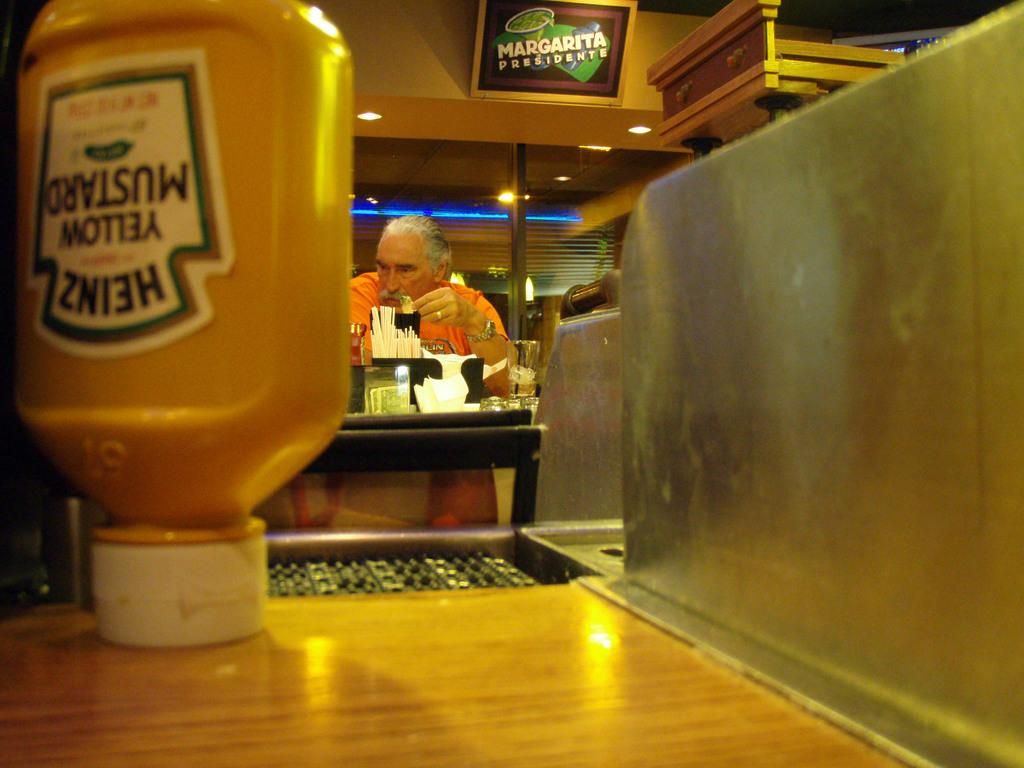Provide a one-sentence caption for the provided image. An upside down mustard bottle rests on the counter at a diner. 